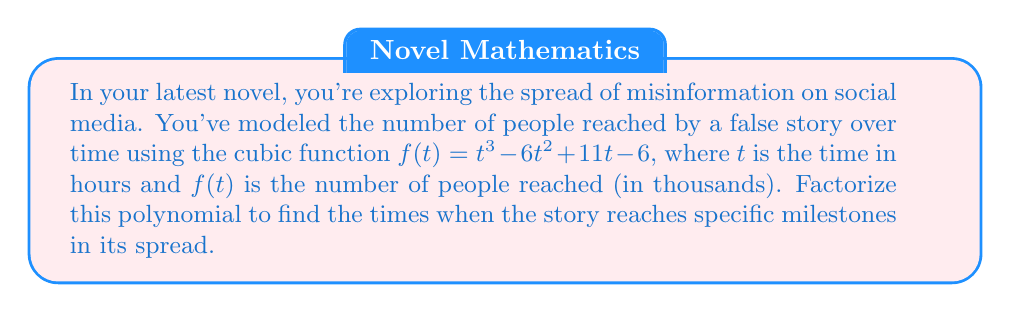Show me your answer to this math problem. To factorize the cubic function $f(t) = t^3 - 6t^2 + 11t - 6$, we'll follow these steps:

1) First, let's check if there's a rational root. We can use the rational root theorem, which states that if a polynomial equation has integer coefficients, then any rational solution, when reduced to lowest terms, will have a numerator that divides the constant term and a denominator that divides the leading coefficient.

   Possible rational roots: $\pm 1, \pm 2, \pm 3, \pm 6$

2) Testing these values, we find that $f(1) = 0$. So $(t-1)$ is a factor.

3) We can now use polynomial long division to divide $f(t)$ by $(t-1)$:

   $t^3 - 6t^2 + 11t - 6 = (t-1)(t^2 - 5t + 6)$

4) Now we need to factorize $t^2 - 5t + 6$. We can do this by finding two numbers that multiply to give 6 and add to give -5. These numbers are -2 and -3.

5) Therefore, $t^2 - 5t + 6 = (t-2)(t-3)$

6) Putting it all together, we get:

   $f(t) = t^3 - 6t^2 + 11t - 6 = (t-1)(t-2)(t-3)$

This factorization reveals that the story reaches specific milestones at $t = 1$, $t = 2$, and $t = 3$ hours after its initial release.
Answer: $(t-1)(t-2)(t-3)$ 